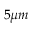<formula> <loc_0><loc_0><loc_500><loc_500>{ 5 } { \mu m }</formula> 